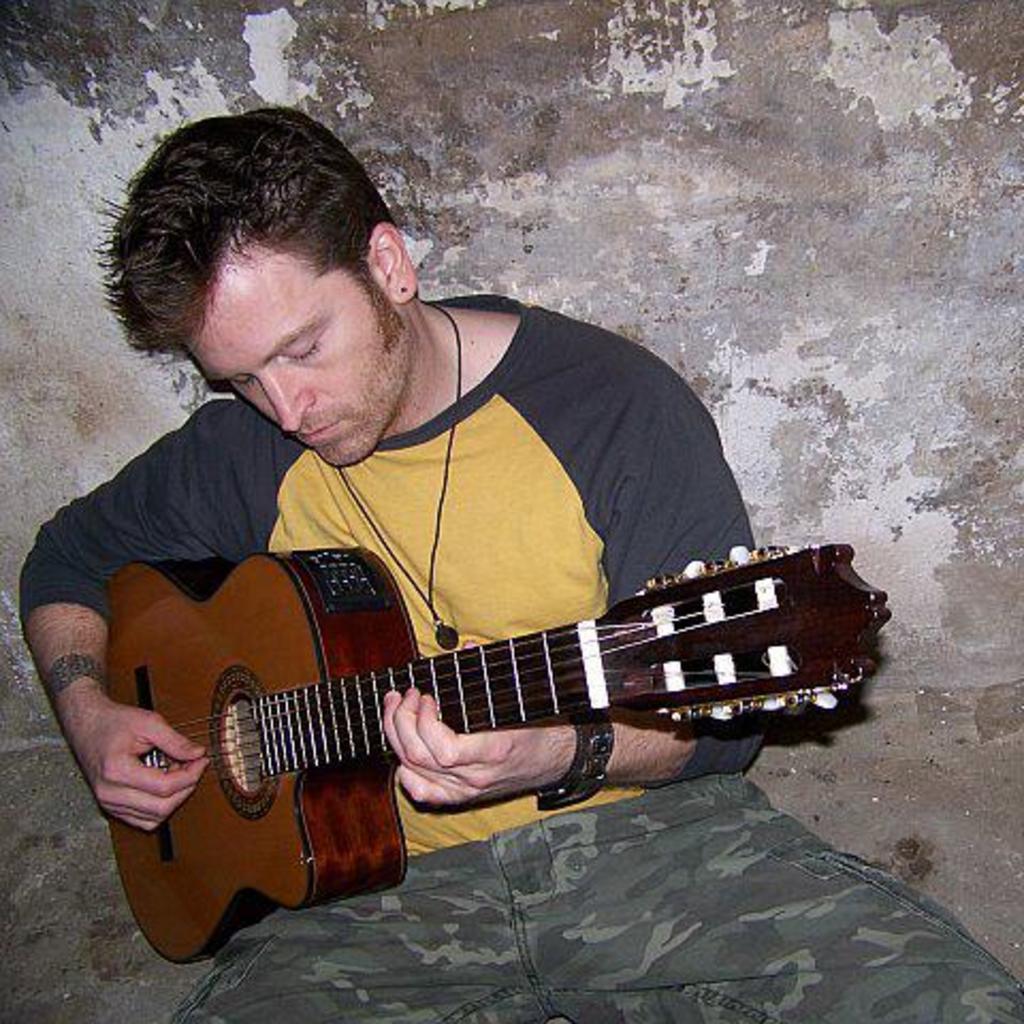Can you describe this image briefly? Here we can see a person who is sitting and holding a guitar and is probably playing the guitar 